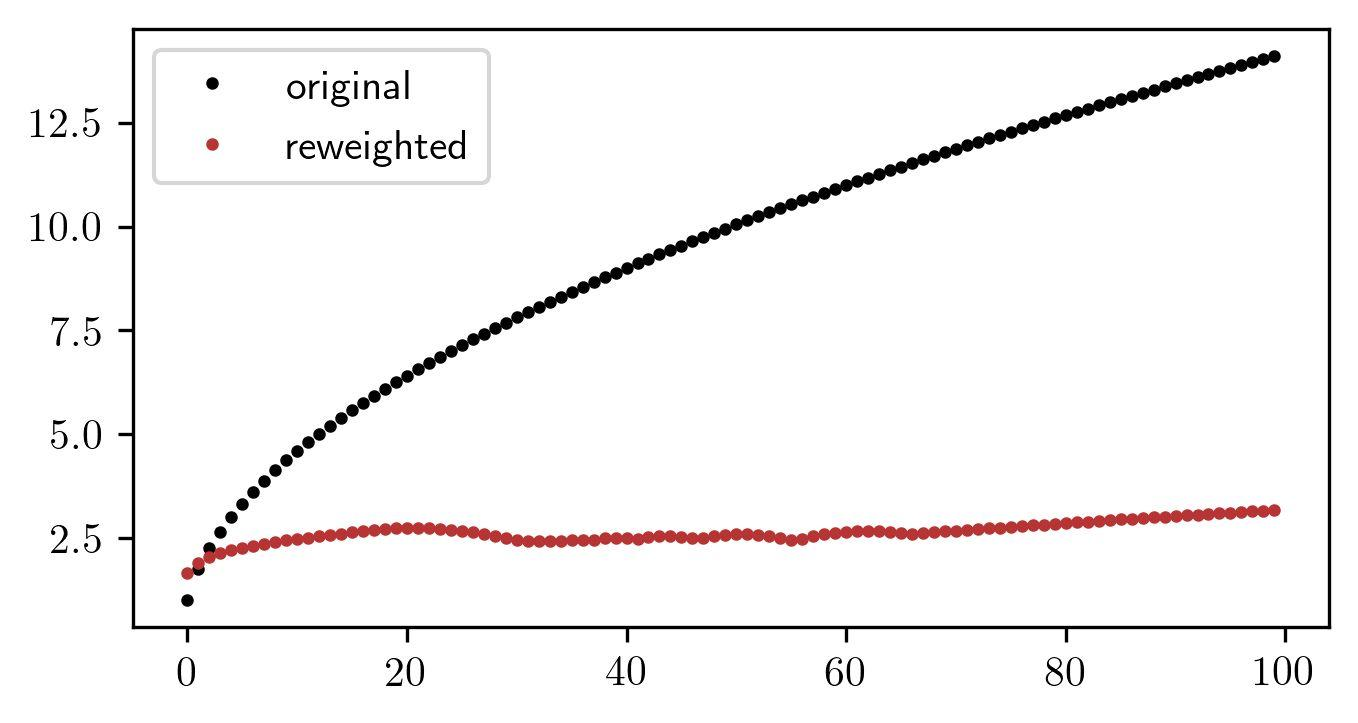How would you describe the distribution of the original data points? The original data points show a linear distribution with a positive slope, suggesting a direct relationship between the x and y variables. The spread is even and there appears to be no significant variance in the data as the x-value increases. This type of distribution indicates a consistent rate of growth or an increase in the variable measured along the y-axis in relation to the x-axis. If this were a time series data, for instance, it could point toward a continual rise over time with no major fluctuations, implying steady progress or escalation of the phenomenon being measured. 